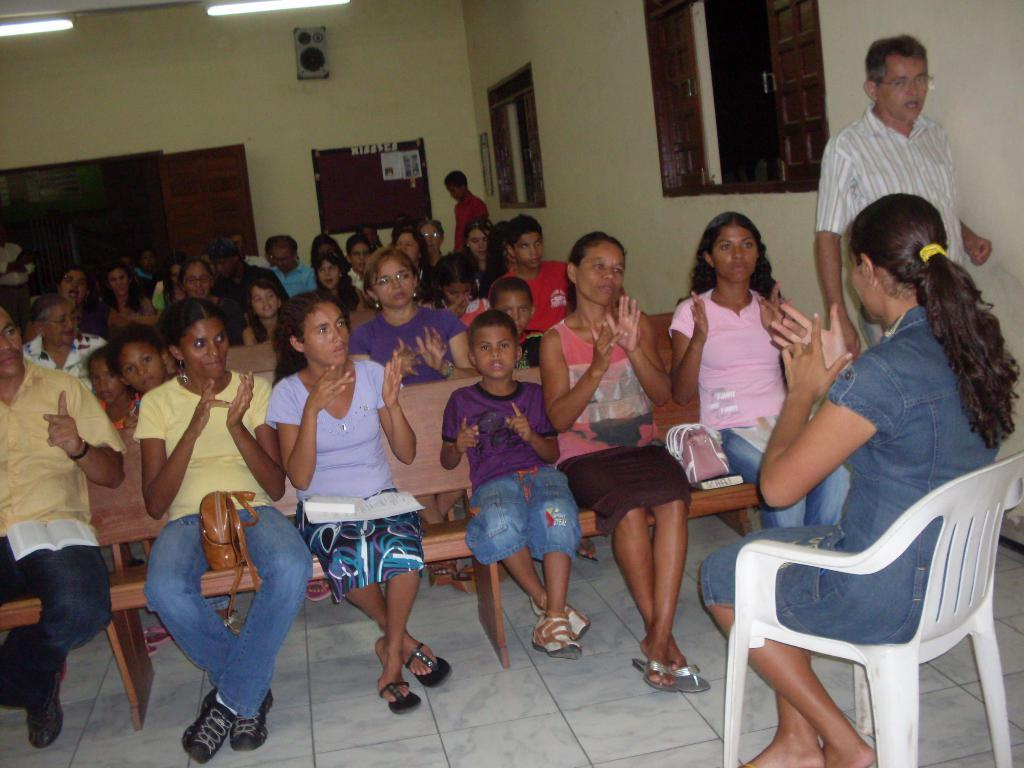How many people are in the image? There are many children in the image. What are some people doing in the image? People are sitting on a bench, and a man is walking in the image. What type of furniture is present in the image? There is a chair in the image, and a woman is sitting on it. Can you describe the man who is walking in the image? The man is wearing spectacles. What type of coal is being traded by the children in the image? There is no mention of coal or trading in the image; it features children and people sitting on a bench. 